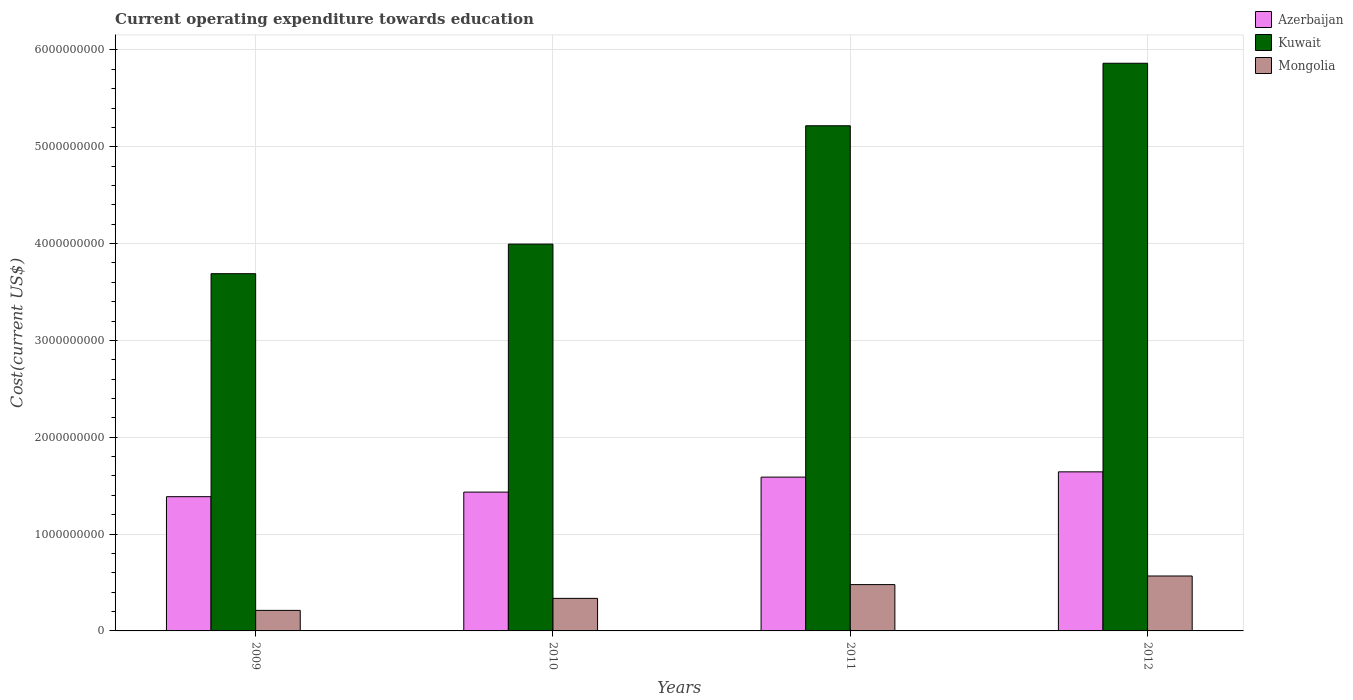How many different coloured bars are there?
Your response must be concise. 3. Are the number of bars per tick equal to the number of legend labels?
Your answer should be very brief. Yes. Are the number of bars on each tick of the X-axis equal?
Give a very brief answer. Yes. What is the expenditure towards education in Kuwait in 2009?
Provide a short and direct response. 3.69e+09. Across all years, what is the maximum expenditure towards education in Kuwait?
Provide a short and direct response. 5.86e+09. Across all years, what is the minimum expenditure towards education in Mongolia?
Your answer should be very brief. 2.12e+08. In which year was the expenditure towards education in Mongolia minimum?
Offer a very short reply. 2009. What is the total expenditure towards education in Azerbaijan in the graph?
Make the answer very short. 6.05e+09. What is the difference between the expenditure towards education in Mongolia in 2009 and that in 2012?
Offer a very short reply. -3.55e+08. What is the difference between the expenditure towards education in Azerbaijan in 2009 and the expenditure towards education in Mongolia in 2012?
Ensure brevity in your answer.  8.19e+08. What is the average expenditure towards education in Mongolia per year?
Provide a succinct answer. 3.98e+08. In the year 2010, what is the difference between the expenditure towards education in Azerbaijan and expenditure towards education in Mongolia?
Provide a succinct answer. 1.10e+09. What is the ratio of the expenditure towards education in Kuwait in 2010 to that in 2011?
Provide a succinct answer. 0.77. Is the difference between the expenditure towards education in Azerbaijan in 2010 and 2011 greater than the difference between the expenditure towards education in Mongolia in 2010 and 2011?
Ensure brevity in your answer.  No. What is the difference between the highest and the second highest expenditure towards education in Azerbaijan?
Offer a very short reply. 5.43e+07. What is the difference between the highest and the lowest expenditure towards education in Azerbaijan?
Keep it short and to the point. 2.56e+08. What does the 2nd bar from the left in 2010 represents?
Offer a terse response. Kuwait. What does the 3rd bar from the right in 2009 represents?
Your answer should be very brief. Azerbaijan. Are all the bars in the graph horizontal?
Ensure brevity in your answer.  No. How many years are there in the graph?
Your answer should be compact. 4. What is the difference between two consecutive major ticks on the Y-axis?
Give a very brief answer. 1.00e+09. What is the title of the graph?
Provide a short and direct response. Current operating expenditure towards education. What is the label or title of the X-axis?
Offer a terse response. Years. What is the label or title of the Y-axis?
Provide a short and direct response. Cost(current US$). What is the Cost(current US$) in Azerbaijan in 2009?
Your response must be concise. 1.39e+09. What is the Cost(current US$) in Kuwait in 2009?
Provide a short and direct response. 3.69e+09. What is the Cost(current US$) in Mongolia in 2009?
Keep it short and to the point. 2.12e+08. What is the Cost(current US$) in Azerbaijan in 2010?
Your answer should be compact. 1.43e+09. What is the Cost(current US$) in Kuwait in 2010?
Your response must be concise. 3.99e+09. What is the Cost(current US$) in Mongolia in 2010?
Offer a terse response. 3.36e+08. What is the Cost(current US$) of Azerbaijan in 2011?
Keep it short and to the point. 1.59e+09. What is the Cost(current US$) of Kuwait in 2011?
Your response must be concise. 5.22e+09. What is the Cost(current US$) in Mongolia in 2011?
Keep it short and to the point. 4.78e+08. What is the Cost(current US$) in Azerbaijan in 2012?
Offer a terse response. 1.64e+09. What is the Cost(current US$) of Kuwait in 2012?
Keep it short and to the point. 5.86e+09. What is the Cost(current US$) in Mongolia in 2012?
Your answer should be compact. 5.67e+08. Across all years, what is the maximum Cost(current US$) in Azerbaijan?
Keep it short and to the point. 1.64e+09. Across all years, what is the maximum Cost(current US$) in Kuwait?
Provide a succinct answer. 5.86e+09. Across all years, what is the maximum Cost(current US$) in Mongolia?
Your response must be concise. 5.67e+08. Across all years, what is the minimum Cost(current US$) of Azerbaijan?
Ensure brevity in your answer.  1.39e+09. Across all years, what is the minimum Cost(current US$) of Kuwait?
Offer a terse response. 3.69e+09. Across all years, what is the minimum Cost(current US$) of Mongolia?
Provide a short and direct response. 2.12e+08. What is the total Cost(current US$) in Azerbaijan in the graph?
Keep it short and to the point. 6.05e+09. What is the total Cost(current US$) in Kuwait in the graph?
Provide a succinct answer. 1.88e+1. What is the total Cost(current US$) in Mongolia in the graph?
Provide a succinct answer. 1.59e+09. What is the difference between the Cost(current US$) in Azerbaijan in 2009 and that in 2010?
Keep it short and to the point. -4.74e+07. What is the difference between the Cost(current US$) in Kuwait in 2009 and that in 2010?
Make the answer very short. -3.06e+08. What is the difference between the Cost(current US$) in Mongolia in 2009 and that in 2010?
Ensure brevity in your answer.  -1.24e+08. What is the difference between the Cost(current US$) of Azerbaijan in 2009 and that in 2011?
Your response must be concise. -2.02e+08. What is the difference between the Cost(current US$) in Kuwait in 2009 and that in 2011?
Make the answer very short. -1.53e+09. What is the difference between the Cost(current US$) of Mongolia in 2009 and that in 2011?
Your response must be concise. -2.66e+08. What is the difference between the Cost(current US$) in Azerbaijan in 2009 and that in 2012?
Your answer should be compact. -2.56e+08. What is the difference between the Cost(current US$) of Kuwait in 2009 and that in 2012?
Offer a very short reply. -2.17e+09. What is the difference between the Cost(current US$) in Mongolia in 2009 and that in 2012?
Keep it short and to the point. -3.55e+08. What is the difference between the Cost(current US$) of Azerbaijan in 2010 and that in 2011?
Offer a very short reply. -1.55e+08. What is the difference between the Cost(current US$) of Kuwait in 2010 and that in 2011?
Make the answer very short. -1.22e+09. What is the difference between the Cost(current US$) in Mongolia in 2010 and that in 2011?
Your response must be concise. -1.42e+08. What is the difference between the Cost(current US$) in Azerbaijan in 2010 and that in 2012?
Your answer should be compact. -2.09e+08. What is the difference between the Cost(current US$) in Kuwait in 2010 and that in 2012?
Provide a short and direct response. -1.87e+09. What is the difference between the Cost(current US$) in Mongolia in 2010 and that in 2012?
Give a very brief answer. -2.31e+08. What is the difference between the Cost(current US$) in Azerbaijan in 2011 and that in 2012?
Provide a succinct answer. -5.43e+07. What is the difference between the Cost(current US$) in Kuwait in 2011 and that in 2012?
Your answer should be compact. -6.45e+08. What is the difference between the Cost(current US$) in Mongolia in 2011 and that in 2012?
Your response must be concise. -8.88e+07. What is the difference between the Cost(current US$) in Azerbaijan in 2009 and the Cost(current US$) in Kuwait in 2010?
Offer a terse response. -2.61e+09. What is the difference between the Cost(current US$) of Azerbaijan in 2009 and the Cost(current US$) of Mongolia in 2010?
Keep it short and to the point. 1.05e+09. What is the difference between the Cost(current US$) in Kuwait in 2009 and the Cost(current US$) in Mongolia in 2010?
Your response must be concise. 3.35e+09. What is the difference between the Cost(current US$) in Azerbaijan in 2009 and the Cost(current US$) in Kuwait in 2011?
Offer a very short reply. -3.83e+09. What is the difference between the Cost(current US$) in Azerbaijan in 2009 and the Cost(current US$) in Mongolia in 2011?
Provide a short and direct response. 9.08e+08. What is the difference between the Cost(current US$) of Kuwait in 2009 and the Cost(current US$) of Mongolia in 2011?
Ensure brevity in your answer.  3.21e+09. What is the difference between the Cost(current US$) of Azerbaijan in 2009 and the Cost(current US$) of Kuwait in 2012?
Offer a very short reply. -4.48e+09. What is the difference between the Cost(current US$) of Azerbaijan in 2009 and the Cost(current US$) of Mongolia in 2012?
Offer a very short reply. 8.19e+08. What is the difference between the Cost(current US$) in Kuwait in 2009 and the Cost(current US$) in Mongolia in 2012?
Offer a terse response. 3.12e+09. What is the difference between the Cost(current US$) of Azerbaijan in 2010 and the Cost(current US$) of Kuwait in 2011?
Provide a short and direct response. -3.78e+09. What is the difference between the Cost(current US$) of Azerbaijan in 2010 and the Cost(current US$) of Mongolia in 2011?
Your response must be concise. 9.55e+08. What is the difference between the Cost(current US$) of Kuwait in 2010 and the Cost(current US$) of Mongolia in 2011?
Provide a succinct answer. 3.52e+09. What is the difference between the Cost(current US$) of Azerbaijan in 2010 and the Cost(current US$) of Kuwait in 2012?
Ensure brevity in your answer.  -4.43e+09. What is the difference between the Cost(current US$) in Azerbaijan in 2010 and the Cost(current US$) in Mongolia in 2012?
Give a very brief answer. 8.66e+08. What is the difference between the Cost(current US$) of Kuwait in 2010 and the Cost(current US$) of Mongolia in 2012?
Your answer should be compact. 3.43e+09. What is the difference between the Cost(current US$) in Azerbaijan in 2011 and the Cost(current US$) in Kuwait in 2012?
Ensure brevity in your answer.  -4.27e+09. What is the difference between the Cost(current US$) in Azerbaijan in 2011 and the Cost(current US$) in Mongolia in 2012?
Give a very brief answer. 1.02e+09. What is the difference between the Cost(current US$) of Kuwait in 2011 and the Cost(current US$) of Mongolia in 2012?
Ensure brevity in your answer.  4.65e+09. What is the average Cost(current US$) in Azerbaijan per year?
Provide a short and direct response. 1.51e+09. What is the average Cost(current US$) in Kuwait per year?
Ensure brevity in your answer.  4.69e+09. What is the average Cost(current US$) in Mongolia per year?
Keep it short and to the point. 3.98e+08. In the year 2009, what is the difference between the Cost(current US$) of Azerbaijan and Cost(current US$) of Kuwait?
Keep it short and to the point. -2.30e+09. In the year 2009, what is the difference between the Cost(current US$) of Azerbaijan and Cost(current US$) of Mongolia?
Ensure brevity in your answer.  1.17e+09. In the year 2009, what is the difference between the Cost(current US$) of Kuwait and Cost(current US$) of Mongolia?
Ensure brevity in your answer.  3.48e+09. In the year 2010, what is the difference between the Cost(current US$) in Azerbaijan and Cost(current US$) in Kuwait?
Your answer should be compact. -2.56e+09. In the year 2010, what is the difference between the Cost(current US$) in Azerbaijan and Cost(current US$) in Mongolia?
Your answer should be compact. 1.10e+09. In the year 2010, what is the difference between the Cost(current US$) of Kuwait and Cost(current US$) of Mongolia?
Make the answer very short. 3.66e+09. In the year 2011, what is the difference between the Cost(current US$) of Azerbaijan and Cost(current US$) of Kuwait?
Give a very brief answer. -3.63e+09. In the year 2011, what is the difference between the Cost(current US$) of Azerbaijan and Cost(current US$) of Mongolia?
Keep it short and to the point. 1.11e+09. In the year 2011, what is the difference between the Cost(current US$) in Kuwait and Cost(current US$) in Mongolia?
Provide a succinct answer. 4.74e+09. In the year 2012, what is the difference between the Cost(current US$) in Azerbaijan and Cost(current US$) in Kuwait?
Your answer should be compact. -4.22e+09. In the year 2012, what is the difference between the Cost(current US$) in Azerbaijan and Cost(current US$) in Mongolia?
Keep it short and to the point. 1.08e+09. In the year 2012, what is the difference between the Cost(current US$) of Kuwait and Cost(current US$) of Mongolia?
Offer a very short reply. 5.30e+09. What is the ratio of the Cost(current US$) of Azerbaijan in 2009 to that in 2010?
Keep it short and to the point. 0.97. What is the ratio of the Cost(current US$) of Kuwait in 2009 to that in 2010?
Offer a very short reply. 0.92. What is the ratio of the Cost(current US$) in Mongolia in 2009 to that in 2010?
Ensure brevity in your answer.  0.63. What is the ratio of the Cost(current US$) in Azerbaijan in 2009 to that in 2011?
Make the answer very short. 0.87. What is the ratio of the Cost(current US$) in Kuwait in 2009 to that in 2011?
Your answer should be very brief. 0.71. What is the ratio of the Cost(current US$) of Mongolia in 2009 to that in 2011?
Your answer should be compact. 0.44. What is the ratio of the Cost(current US$) in Azerbaijan in 2009 to that in 2012?
Your response must be concise. 0.84. What is the ratio of the Cost(current US$) of Kuwait in 2009 to that in 2012?
Make the answer very short. 0.63. What is the ratio of the Cost(current US$) in Mongolia in 2009 to that in 2012?
Provide a short and direct response. 0.37. What is the ratio of the Cost(current US$) in Azerbaijan in 2010 to that in 2011?
Provide a succinct answer. 0.9. What is the ratio of the Cost(current US$) of Kuwait in 2010 to that in 2011?
Make the answer very short. 0.77. What is the ratio of the Cost(current US$) in Mongolia in 2010 to that in 2011?
Give a very brief answer. 0.7. What is the ratio of the Cost(current US$) of Azerbaijan in 2010 to that in 2012?
Make the answer very short. 0.87. What is the ratio of the Cost(current US$) in Kuwait in 2010 to that in 2012?
Give a very brief answer. 0.68. What is the ratio of the Cost(current US$) of Mongolia in 2010 to that in 2012?
Offer a very short reply. 0.59. What is the ratio of the Cost(current US$) in Azerbaijan in 2011 to that in 2012?
Offer a terse response. 0.97. What is the ratio of the Cost(current US$) in Kuwait in 2011 to that in 2012?
Your answer should be very brief. 0.89. What is the ratio of the Cost(current US$) of Mongolia in 2011 to that in 2012?
Your response must be concise. 0.84. What is the difference between the highest and the second highest Cost(current US$) of Azerbaijan?
Provide a succinct answer. 5.43e+07. What is the difference between the highest and the second highest Cost(current US$) in Kuwait?
Provide a succinct answer. 6.45e+08. What is the difference between the highest and the second highest Cost(current US$) of Mongolia?
Make the answer very short. 8.88e+07. What is the difference between the highest and the lowest Cost(current US$) in Azerbaijan?
Offer a terse response. 2.56e+08. What is the difference between the highest and the lowest Cost(current US$) of Kuwait?
Offer a very short reply. 2.17e+09. What is the difference between the highest and the lowest Cost(current US$) of Mongolia?
Provide a succinct answer. 3.55e+08. 